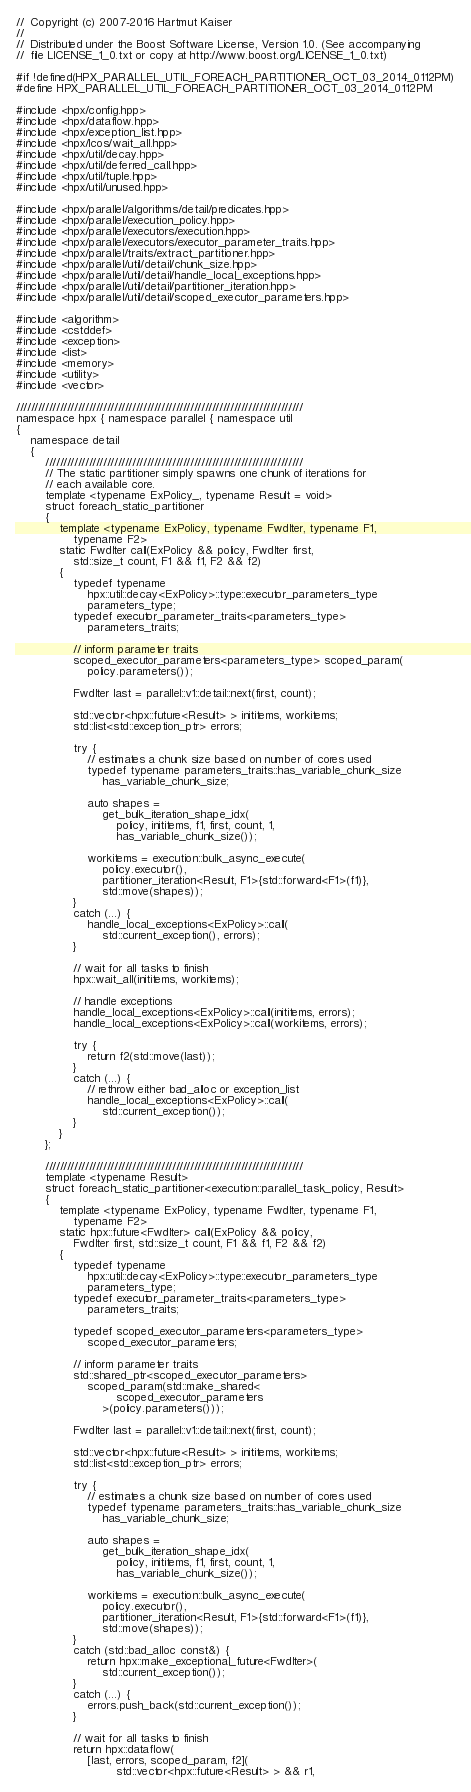Convert code to text. <code><loc_0><loc_0><loc_500><loc_500><_C++_>//  Copyright (c) 2007-2016 Hartmut Kaiser
//
//  Distributed under the Boost Software License, Version 1.0. (See accompanying
//  file LICENSE_1_0.txt or copy at http://www.boost.org/LICENSE_1_0.txt)

#if !defined(HPX_PARALLEL_UTIL_FOREACH_PARTITIONER_OCT_03_2014_0112PM)
#define HPX_PARALLEL_UTIL_FOREACH_PARTITIONER_OCT_03_2014_0112PM

#include <hpx/config.hpp>
#include <hpx/dataflow.hpp>
#include <hpx/exception_list.hpp>
#include <hpx/lcos/wait_all.hpp>
#include <hpx/util/decay.hpp>
#include <hpx/util/deferred_call.hpp>
#include <hpx/util/tuple.hpp>
#include <hpx/util/unused.hpp>

#include <hpx/parallel/algorithms/detail/predicates.hpp>
#include <hpx/parallel/execution_policy.hpp>
#include <hpx/parallel/executors/execution.hpp>
#include <hpx/parallel/executors/executor_parameter_traits.hpp>
#include <hpx/parallel/traits/extract_partitioner.hpp>
#include <hpx/parallel/util/detail/chunk_size.hpp>
#include <hpx/parallel/util/detail/handle_local_exceptions.hpp>
#include <hpx/parallel/util/detail/partitioner_iteration.hpp>
#include <hpx/parallel/util/detail/scoped_executor_parameters.hpp>

#include <algorithm>
#include <cstddef>
#include <exception>
#include <list>
#include <memory>
#include <utility>
#include <vector>

///////////////////////////////////////////////////////////////////////////////
namespace hpx { namespace parallel { namespace util
{
    namespace detail
    {
        ///////////////////////////////////////////////////////////////////////
        // The static partitioner simply spawns one chunk of iterations for
        // each available core.
        template <typename ExPolicy_, typename Result = void>
        struct foreach_static_partitioner
        {
            template <typename ExPolicy, typename FwdIter, typename F1,
                typename F2>
            static FwdIter call(ExPolicy && policy, FwdIter first,
                std::size_t count, F1 && f1, F2 && f2)
            {
                typedef typename
                    hpx::util::decay<ExPolicy>::type::executor_parameters_type
                    parameters_type;
                typedef executor_parameter_traits<parameters_type>
                    parameters_traits;

                // inform parameter traits
                scoped_executor_parameters<parameters_type> scoped_param(
                    policy.parameters());

                FwdIter last = parallel::v1::detail::next(first, count);

                std::vector<hpx::future<Result> > inititems, workitems;
                std::list<std::exception_ptr> errors;

                try {
                    // estimates a chunk size based on number of cores used
                    typedef typename parameters_traits::has_variable_chunk_size
                        has_variable_chunk_size;

                    auto shapes =
                        get_bulk_iteration_shape_idx(
                            policy, inititems, f1, first, count, 1,
                            has_variable_chunk_size());

                    workitems = execution::bulk_async_execute(
                        policy.executor(),
                        partitioner_iteration<Result, F1>{std::forward<F1>(f1)},
                        std::move(shapes));
                }
                catch (...) {
                    handle_local_exceptions<ExPolicy>::call(
                        std::current_exception(), errors);
                }

                // wait for all tasks to finish
                hpx::wait_all(inititems, workitems);

                // handle exceptions
                handle_local_exceptions<ExPolicy>::call(inititems, errors);
                handle_local_exceptions<ExPolicy>::call(workitems, errors);

                try {
                    return f2(std::move(last));
                }
                catch (...) {
                    // rethrow either bad_alloc or exception_list
                    handle_local_exceptions<ExPolicy>::call(
                        std::current_exception());
                }
            }
        };

        ///////////////////////////////////////////////////////////////////////
        template <typename Result>
        struct foreach_static_partitioner<execution::parallel_task_policy, Result>
        {
            template <typename ExPolicy, typename FwdIter, typename F1,
                typename F2>
            static hpx::future<FwdIter> call(ExPolicy && policy,
                FwdIter first, std::size_t count, F1 && f1, F2 && f2)
            {
                typedef typename
                    hpx::util::decay<ExPolicy>::type::executor_parameters_type
                    parameters_type;
                typedef executor_parameter_traits<parameters_type>
                    parameters_traits;

                typedef scoped_executor_parameters<parameters_type>
                    scoped_executor_parameters;

                // inform parameter traits
                std::shared_ptr<scoped_executor_parameters>
                    scoped_param(std::make_shared<
                            scoped_executor_parameters
                        >(policy.parameters()));

                FwdIter last = parallel::v1::detail::next(first, count);

                std::vector<hpx::future<Result> > inititems, workitems;
                std::list<std::exception_ptr> errors;

                try {
                    // estimates a chunk size based on number of cores used
                    typedef typename parameters_traits::has_variable_chunk_size
                        has_variable_chunk_size;

                    auto shapes =
                        get_bulk_iteration_shape_idx(
                            policy, inititems, f1, first, count, 1,
                            has_variable_chunk_size());

                    workitems = execution::bulk_async_execute(
                        policy.executor(),
                        partitioner_iteration<Result, F1>{std::forward<F1>(f1)},
                        std::move(shapes));
                }
                catch (std::bad_alloc const&) {
                    return hpx::make_exceptional_future<FwdIter>(
                        std::current_exception());
                }
                catch (...) {
                    errors.push_back(std::current_exception());
                }

                // wait for all tasks to finish
                return hpx::dataflow(
                    [last, errors, scoped_param, f2](
                            std::vector<hpx::future<Result> > && r1,</code> 